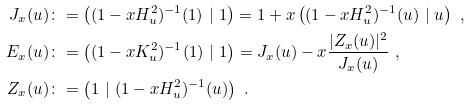<formula> <loc_0><loc_0><loc_500><loc_500>J _ { x } ( u ) & \colon = \left ( ( 1 - x H _ { u } ^ { 2 } ) ^ { - 1 } ( 1 ) \ | \ 1 \right ) = 1 + x \left ( ( 1 - x H _ { u } ^ { 2 } ) ^ { - 1 } ( u ) \ | \ u \right ) \ , \\ E _ { x } ( u ) & \colon = \left ( ( 1 - x K _ { u } ^ { 2 } ) ^ { - 1 } ( 1 ) \ | \ 1 \right ) = J _ { x } ( u ) - x \frac { | Z _ { x } ( u ) | ^ { 2 } } { J _ { x } ( u ) } \ , \\ Z _ { x } ( u ) & \colon = \left ( 1 \ | \ ( 1 - x H _ { u } ^ { 2 } ) ^ { - 1 } ( u ) \right ) \ .</formula> 